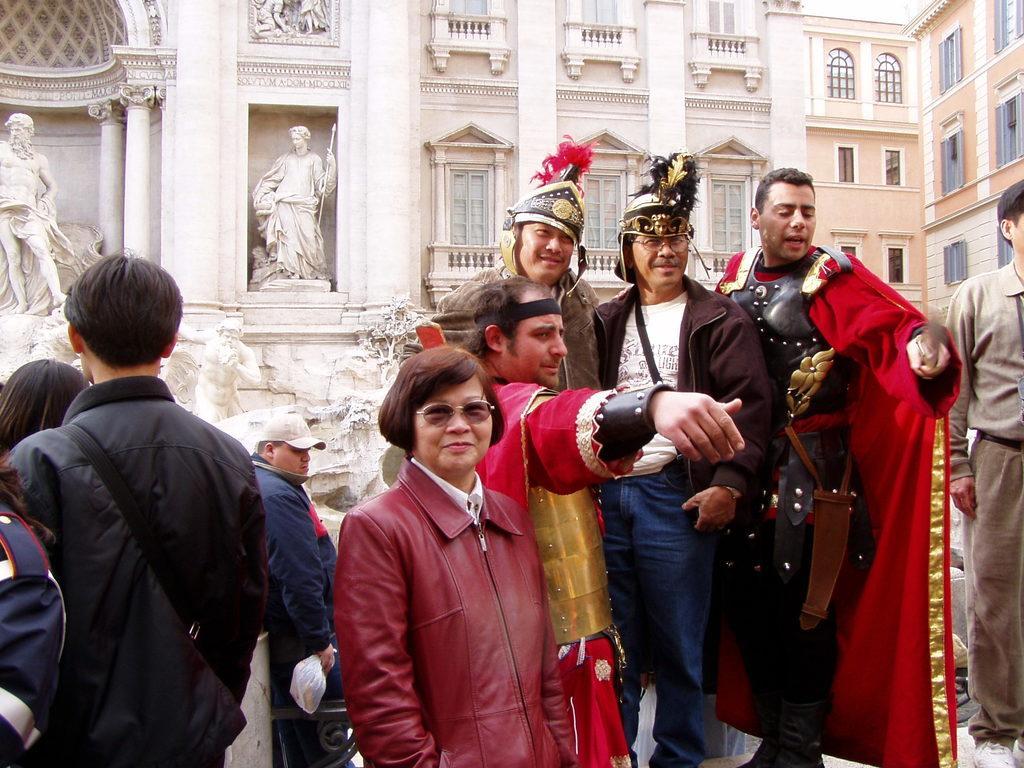Can you describe this image briefly? This is an outside view. Here I can see few people wearing costumes, standing and looking at the right side. On the left side there are few people standing facing towards the back side. In the background, I can see a building along with the windows. On the left side there are two statues placed on a wall and also there are few pillars. 